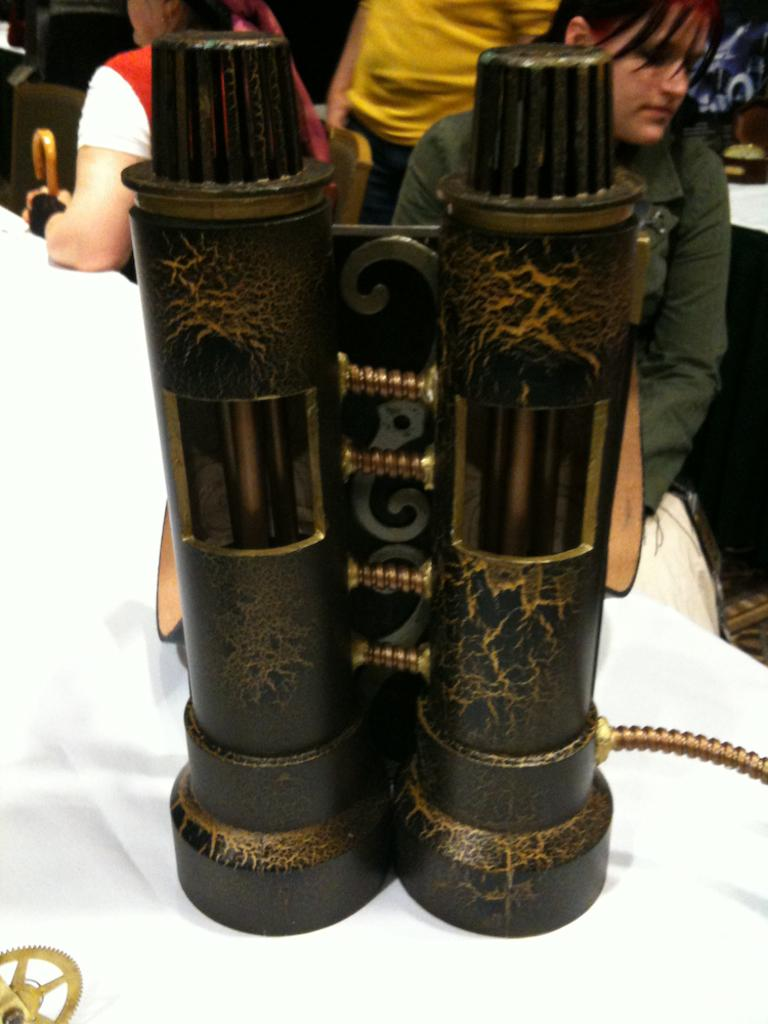What is the main object in the image? There is a binocular in the image. Where is the binocular located? The binocular is on a table. What can be seen in the background of the image? There are two people sitting in the background of the image. What are the people sitting on? The people are sitting on chairs. What type of toys are the people playing with in the image? There are no toys present in the image; it features a binocular on a table and two people sitting in the background. 